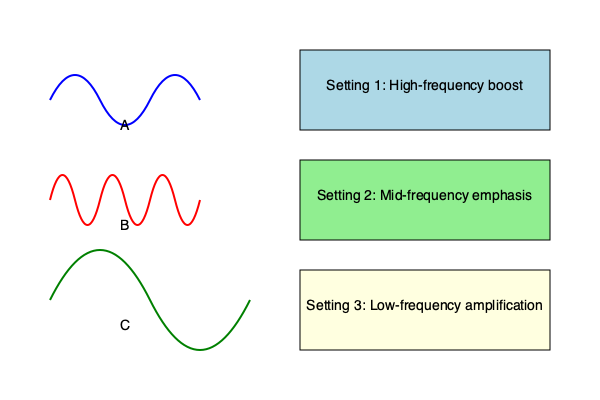Match each auditory waveform (A, B, C) to the most appropriate hearing aid setting (1, 2, 3) for optimal sound amplification. Provide your answer in the format: A-X, B-Y, C-Z, where X, Y, and Z are the corresponding setting numbers. To match the auditory waveforms to the appropriate hearing aid settings, we need to analyze the characteristics of each waveform and relate them to the frequency ranges targeted by each setting:

1. Waveform A:
   - Shows a moderate wavelength with smooth curves
   - Represents mid-range frequencies
   - Best matched with Setting 2: Mid-frequency emphasis

2. Waveform B:
   - Displays short, rapid oscillations
   - Indicates high-frequency sound waves
   - Best matched with Setting 1: High-frequency boost

3. Waveform C:
   - Exhibits long, gradual waves
   - Represents low-frequency sound waves
   - Best matched with Setting 3: Low-frequency amplification

The optimal matching for each waveform to its corresponding hearing aid setting is:
A-2 (mid-frequency)
B-1 (high-frequency)
C-3 (low-frequency)

This matching ensures that each type of sound wave receives the appropriate amplification for optimal hearing improvement in patients with age-related hearing loss.
Answer: A-2, B-1, C-3 